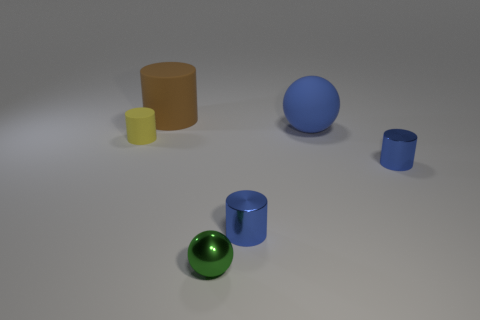The large thing right of the cylinder that is behind the cylinder that is left of the brown rubber cylinder is what color? blue 